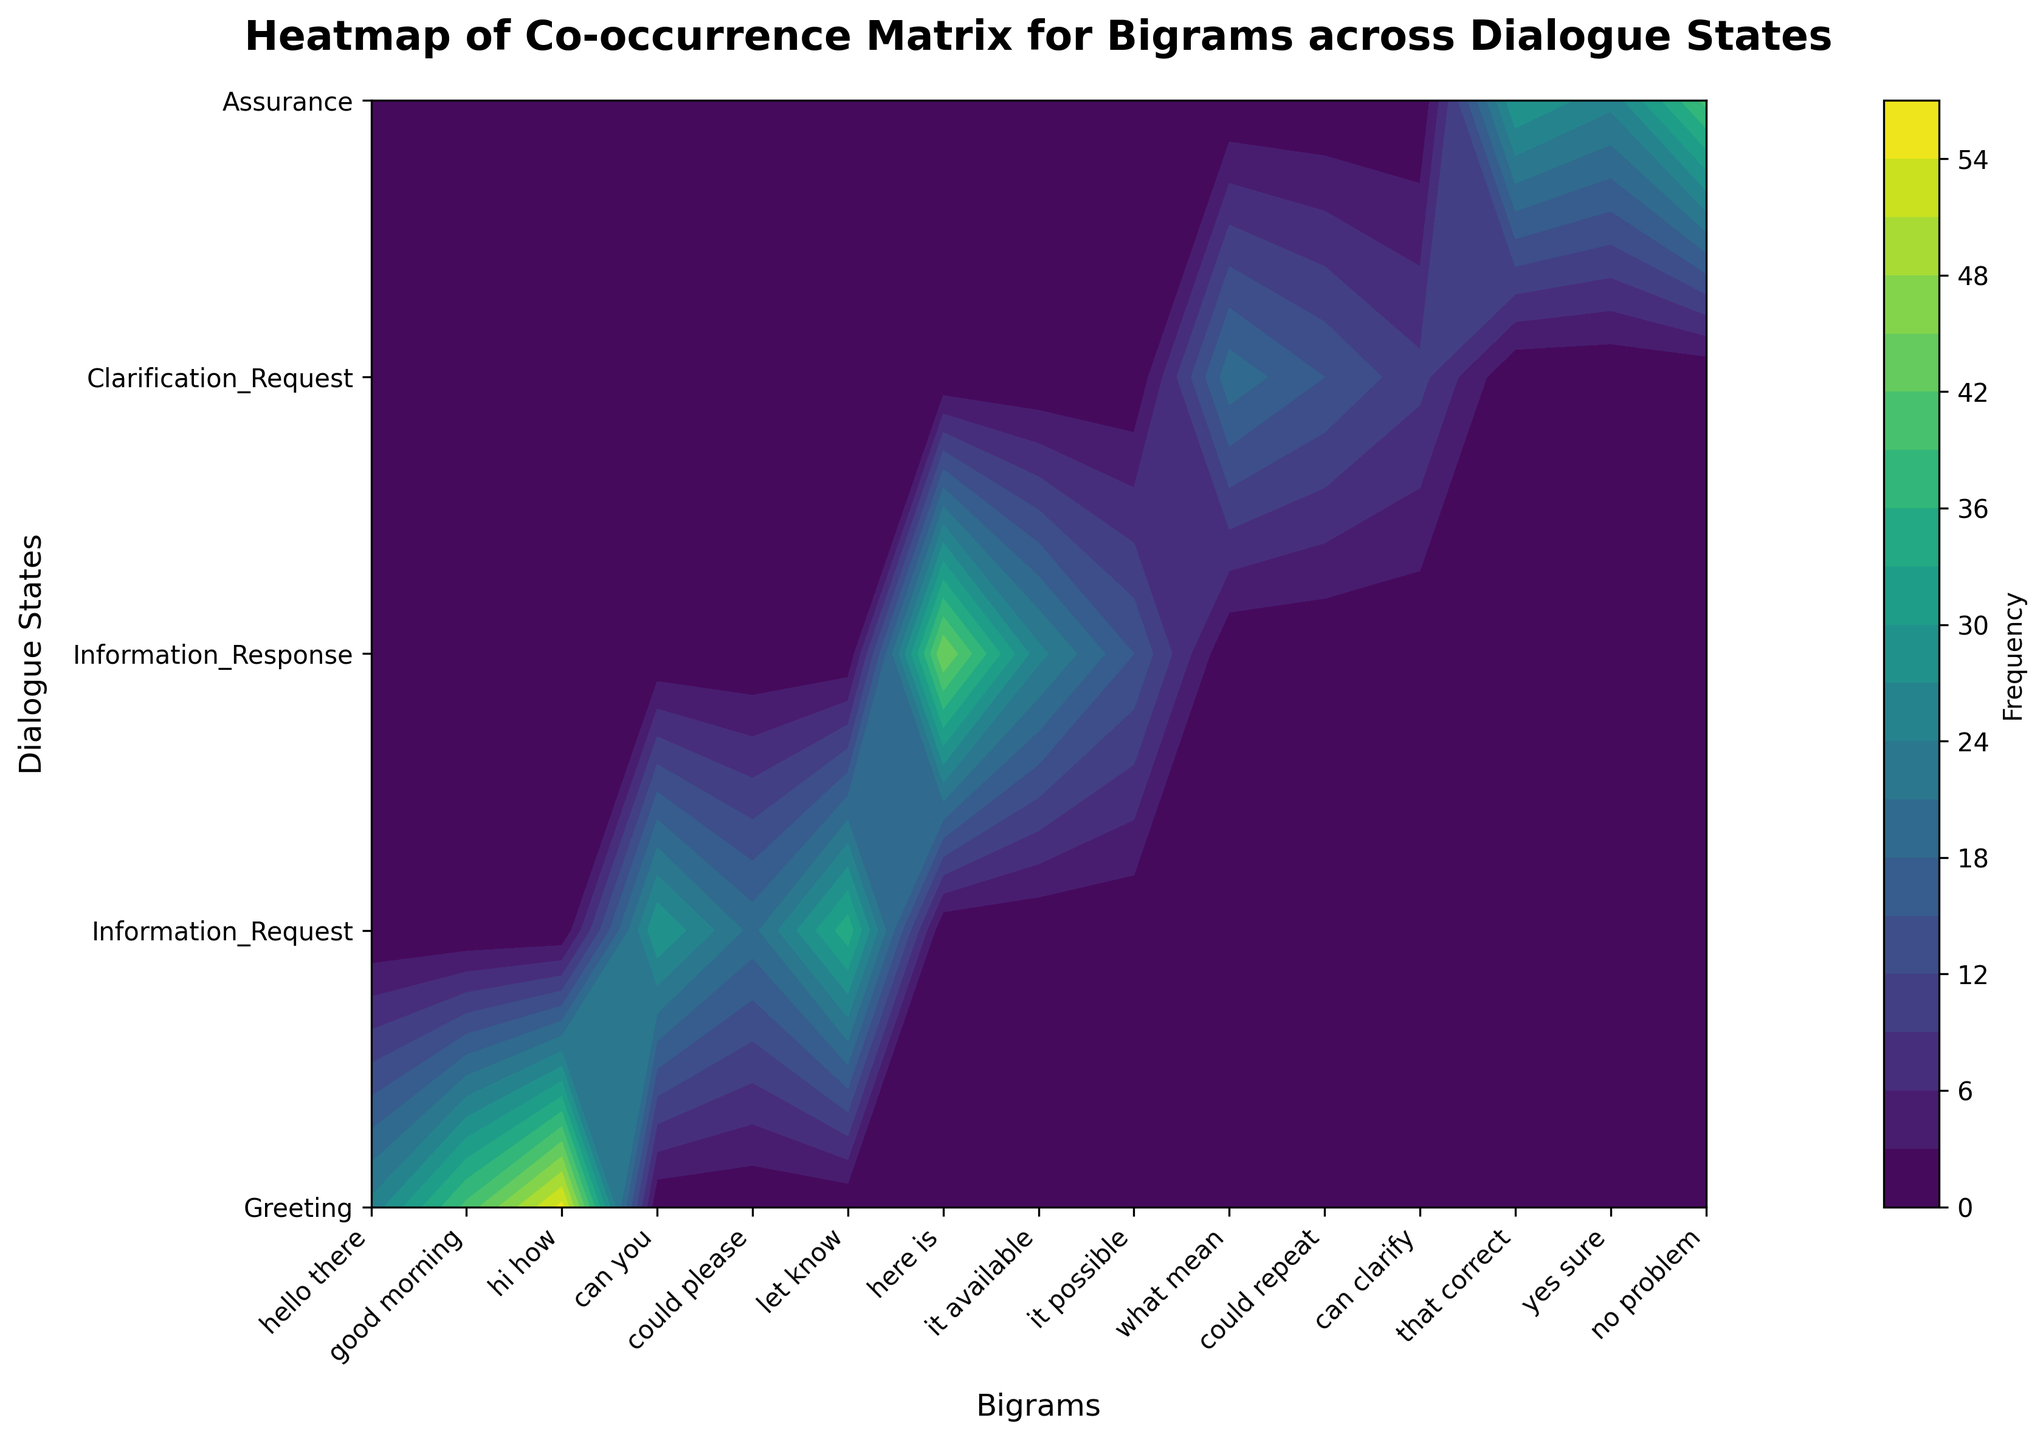What is the title of the figure? The title is typically located at the top of the plot. In this case, it is clearly labeled.
Answer: Heatmap of Co-occurrence Matrix for Bigrams across Dialogue States How many dialogue states are shown in the plot? The number of distinct labels on the y-axis of the plot indicates the number of dialogue states.
Answer: 5 Which bigram has the highest frequency within the 'Greeting' dialogue state? Look for the highest contour level or darkest color within the 'Greeting' row next to the x-axis labels. The darkest color for 'Greeting' corresponds to 'hi how'.
Answer: hi how What is the frequency value of the bigram 'can you' in the 'Information_Request' dialogue state? Locate the 'Information_Request' on the y-axis and find the intersection with 'can you' on the x-axis, then read the contour level or associated color bar.
Answer: 30 Which dialogue state has the least frequent occurrence of the bigram 'it possible'? Find the 'it possible' label on the x-axis and identify the dialogue state with the lightest color or lowest contour level.
Answer: Information_Response Compare the frequency of 'could repeat' in 'Clarification_Request' with 'no problem' in 'Assurance'. Which one is higher? Locate both combinations on the axis and compare their color intensities or contour levels. 'no problem' in 'Assurance' is higher.
Answer: no problem What is the average frequency of bigrams within the 'Information_Response' dialogue state? Add up the frequencies of all bigrams within 'Information_Response' and divide by the number of bigrams. (45 + 25 + 15) / 3 = 28.33
Answer: 28.33 Which bigram has the highest overall frequency across all dialogue states? Identify the darkest region on the contour plot and refer back to the axis labels.
Answer: hi how How does the frequency of 'could please' in 'Information_Request' compare to the frequency of 'yes sure' in 'Assurance'? Compare the color intensities or contour levels for these specific combinations. 'yes sure' in 'Assurance' has a higher frequency.
Answer: yes sure 